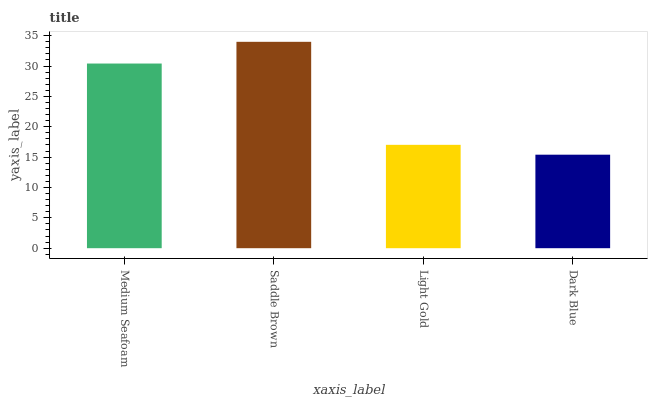Is Dark Blue the minimum?
Answer yes or no. Yes. Is Saddle Brown the maximum?
Answer yes or no. Yes. Is Light Gold the minimum?
Answer yes or no. No. Is Light Gold the maximum?
Answer yes or no. No. Is Saddle Brown greater than Light Gold?
Answer yes or no. Yes. Is Light Gold less than Saddle Brown?
Answer yes or no. Yes. Is Light Gold greater than Saddle Brown?
Answer yes or no. No. Is Saddle Brown less than Light Gold?
Answer yes or no. No. Is Medium Seafoam the high median?
Answer yes or no. Yes. Is Light Gold the low median?
Answer yes or no. Yes. Is Dark Blue the high median?
Answer yes or no. No. Is Saddle Brown the low median?
Answer yes or no. No. 